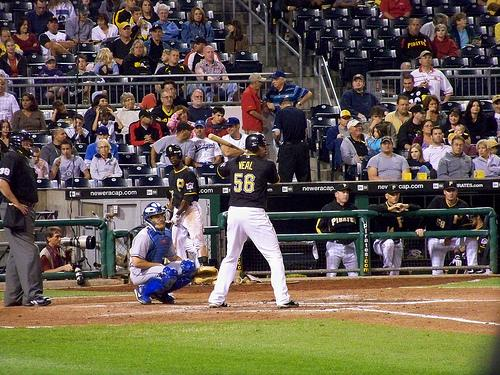Mention two distinct actions that spectators are doing in the image. Some spectators are taking photos and others are conversating, not paying attention to the game. Briefly describe an action performed by the catcher in the image. The catcher is squatting, wearing a blue helmet, blue shin pads, and signaling the pitcher which throw to use. Identify the main sentiment conveyed by this image of people watching and playing baseball. The main sentiment conveyed in the image is excitement and anticipation as the players and spectators are engaged in the baseball game. What is the characteristic feature of the baseball player who holds the bat? The baseball player is wearing a black and yellow tee shirt with a large yellow number 56 on it. What is the baseball player on home base preparing to do? The baseball player is preparing to swing the bat and hit the ball, possibly getting a home run. What does the umpire in the image wear? The umpire wears gray clothes and a black helmet. Count the number of black baseball hats mentioned in the image description. There are 6 black baseball hats mentioned in the image description. Enumerate the colors of different clothing items found in the image. Black and yellow tee shirt, white pants, blue shin pads, gray clothes, red shirt, beige cap, black helmet, white jacket, and striped shirt. What distinguishes the batter's equipment from others in the image? The batter is wearing white pants, a black and yellow tee shirt with number 56, and a black helmet, while holding a bat. Analyze the interaction between the pitcher, batter, catcher, and umpire during the game. The pitcher is preparing to throw the ball; the batter is waiting to hit it; the catcher is squatting, signaling the pitcher which throw to use, and waiting for the ball; and the umpire is standing behind the players, supervising the game in gray clothes and a black helmet. 